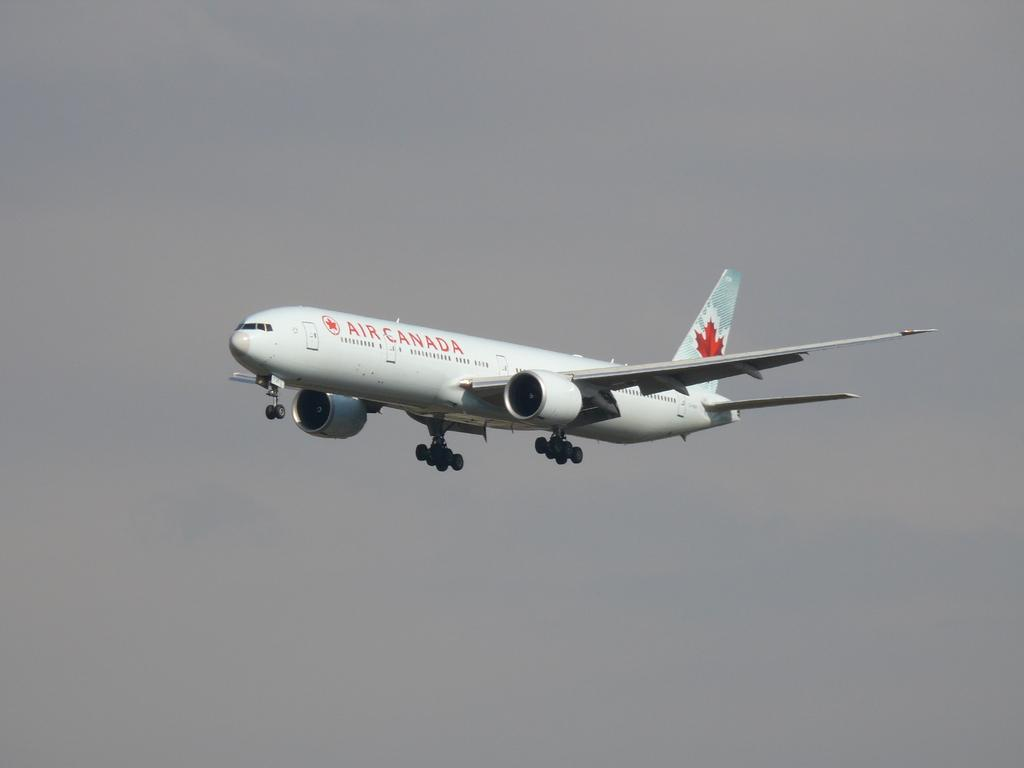<image>
Create a compact narrative representing the image presented. an Air Canada in the plane of the sky 